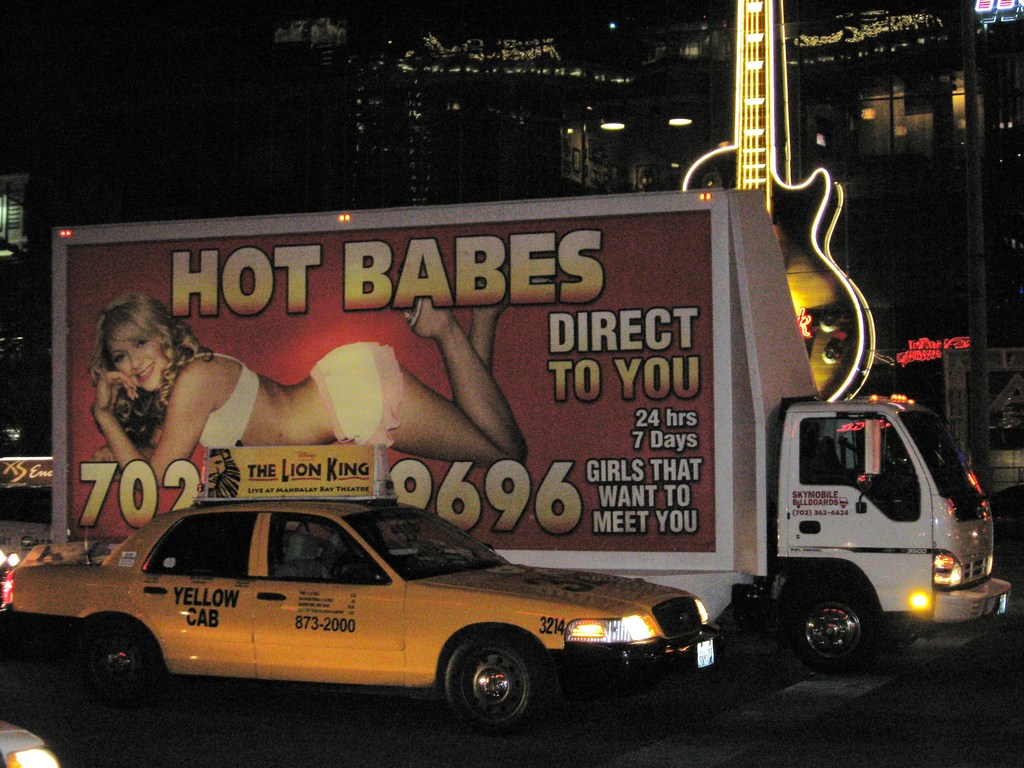What does the advertisement on the billboard suggest about the cultural or commercial environment of this area? The advertisement on the billboard suggests a commercial environment that is bold and direct, likely targeting an adult audience. It emphasizes the area's commercial dynamism where businesses use aggressive marketing strategies to stand out. This might also hint at the cultural openness or the liberal attitudes of the locality towards adult-themed advertising, which could be a characteristic of this urban sector’s nightlife and entertainment scene. 